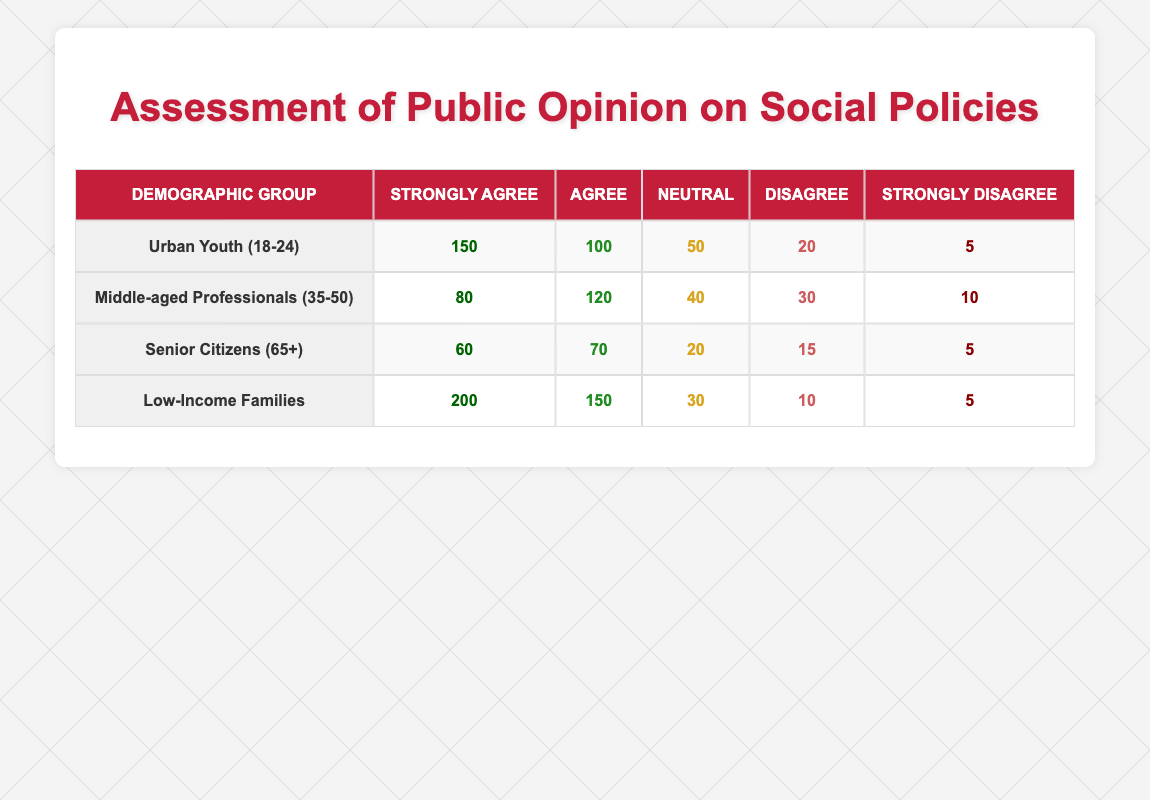What is the total number of respondents from Low-Income Families who Support Social Policies? From the table, we see the breakdown for "Low-Income Families": Strongly Agree (200), Agree (150), Neutral (30), Disagree (10), and Strongly Disagree (5). The total number of respondents can be calculated by summing these values: 200 + 150 + 30 + 10 + 5 = 395.
Answer: 395 Which demographic group has the highest count of Strongly Agree responses? Looking at the table, we see that the counts for Strongly Agree are: Urban Youth (150), Middle-aged Professionals (80), Senior Citizens (60), and Low-Income Families (200). The highest count is 200 from Low-Income Families.
Answer: Low-Income Families What percentage of the Middle-aged Professionals disagreed with social policies? The count for Disagree among Middle-aged Professionals is 30. To find the percentage, we need the total count for that demographic, which is 80 (Strongly Agree) + 120 (Agree) + 40 (Neutral) + 30 (Disagree) + 10 (Strongly Disagree) = 280. Now, 30 is divided by 280 and multiplied by 100 to get the percentage: (30/280) * 100 ≈ 10.71%.
Answer: Approximately 10.71% Is it true that more than half of the Urban Youth (18-24) are in favor of social policies? For Urban Youth, both Strongly Agree (150) and Agree (100) total 250. The counts of Neutral (50), Disagree (20), and Strongly Disagree (5) total 75. Thus, more than half is calculated as 250 > 75. Therefore, the statement is true.
Answer: Yes What is the average count of Strongly Agree responses across all demographic groups? The counts for Strongly Agree are: Urban Youth (150), Middle-aged Professionals (80), Senior Citizens (60), and Low-Income Families (200). The total is 150 + 80 + 60 + 200 = 490. There are 4 groups, so the average is 490 / 4 = 122.5.
Answer: 122.5 